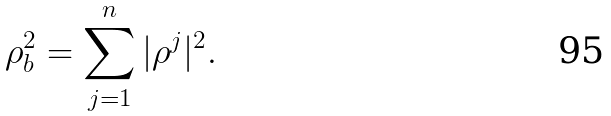Convert formula to latex. <formula><loc_0><loc_0><loc_500><loc_500>\rho _ { b } ^ { 2 } = \sum _ { j = 1 } ^ { n } | \rho ^ { j } | ^ { 2 } .</formula> 